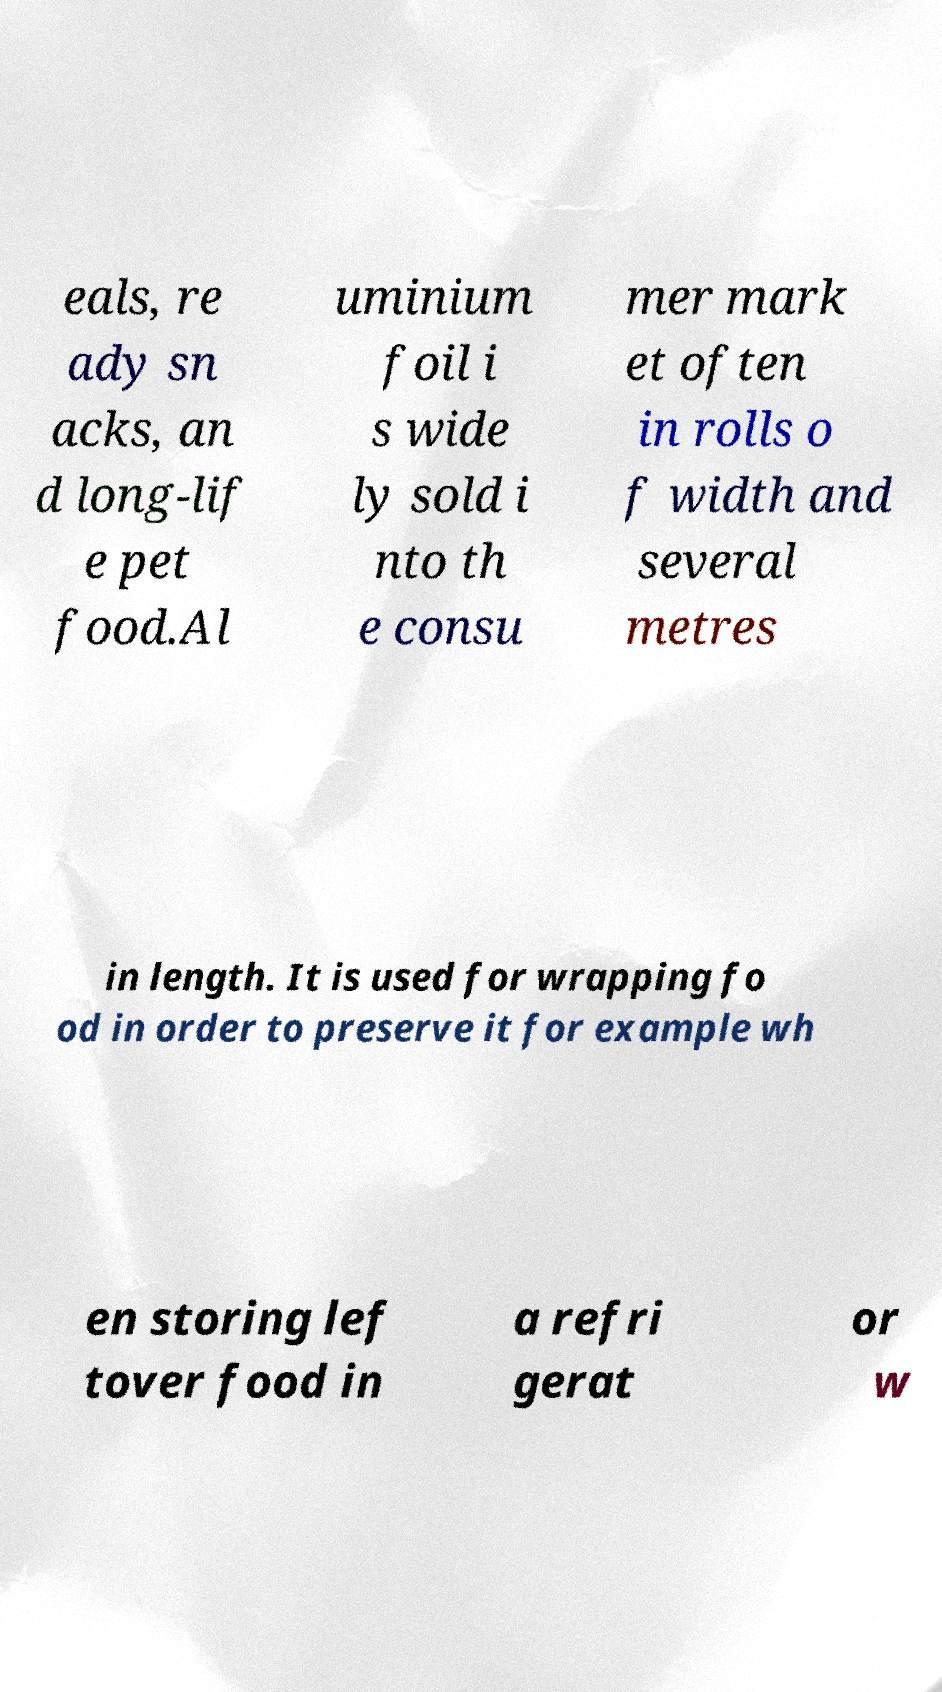Could you extract and type out the text from this image? eals, re ady sn acks, an d long-lif e pet food.Al uminium foil i s wide ly sold i nto th e consu mer mark et often in rolls o f width and several metres in length. It is used for wrapping fo od in order to preserve it for example wh en storing lef tover food in a refri gerat or w 